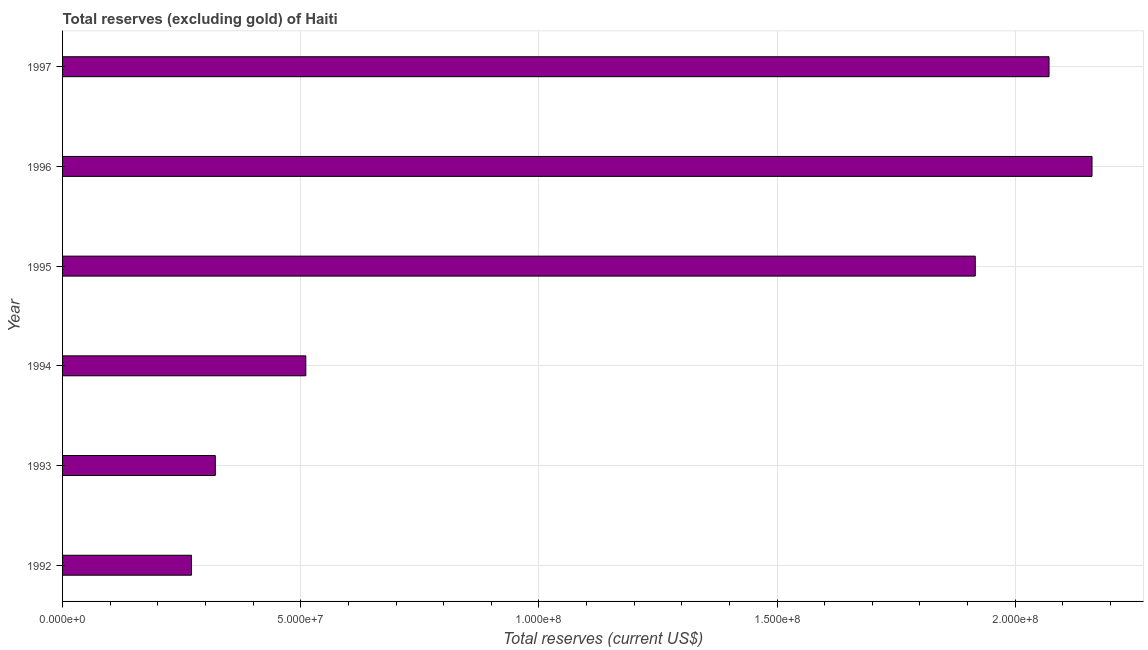Does the graph contain any zero values?
Provide a succinct answer. No. What is the title of the graph?
Your answer should be compact. Total reserves (excluding gold) of Haiti. What is the label or title of the X-axis?
Ensure brevity in your answer.  Total reserves (current US$). What is the label or title of the Y-axis?
Provide a succinct answer. Year. What is the total reserves (excluding gold) in 1992?
Offer a very short reply. 2.71e+07. Across all years, what is the maximum total reserves (excluding gold)?
Your answer should be very brief. 2.16e+08. Across all years, what is the minimum total reserves (excluding gold)?
Keep it short and to the point. 2.71e+07. What is the sum of the total reserves (excluding gold)?
Provide a short and direct response. 7.25e+08. What is the difference between the total reserves (excluding gold) in 1992 and 1993?
Your answer should be very brief. -4.99e+06. What is the average total reserves (excluding gold) per year?
Your response must be concise. 1.21e+08. What is the median total reserves (excluding gold)?
Offer a very short reply. 1.21e+08. What is the ratio of the total reserves (excluding gold) in 1993 to that in 1995?
Make the answer very short. 0.17. Is the total reserves (excluding gold) in 1992 less than that in 1997?
Your answer should be compact. Yes. What is the difference between the highest and the second highest total reserves (excluding gold)?
Your response must be concise. 9.03e+06. Is the sum of the total reserves (excluding gold) in 1992 and 1997 greater than the maximum total reserves (excluding gold) across all years?
Offer a very short reply. Yes. What is the difference between the highest and the lowest total reserves (excluding gold)?
Your answer should be very brief. 1.89e+08. In how many years, is the total reserves (excluding gold) greater than the average total reserves (excluding gold) taken over all years?
Ensure brevity in your answer.  3. Are all the bars in the graph horizontal?
Your answer should be very brief. Yes. How many years are there in the graph?
Provide a succinct answer. 6. What is the difference between two consecutive major ticks on the X-axis?
Offer a terse response. 5.00e+07. What is the Total reserves (current US$) in 1992?
Provide a succinct answer. 2.71e+07. What is the Total reserves (current US$) of 1993?
Keep it short and to the point. 3.21e+07. What is the Total reserves (current US$) of 1994?
Provide a succinct answer. 5.11e+07. What is the Total reserves (current US$) in 1995?
Your answer should be very brief. 1.92e+08. What is the Total reserves (current US$) in 1996?
Keep it short and to the point. 2.16e+08. What is the Total reserves (current US$) of 1997?
Keep it short and to the point. 2.07e+08. What is the difference between the Total reserves (current US$) in 1992 and 1993?
Provide a succinct answer. -4.99e+06. What is the difference between the Total reserves (current US$) in 1992 and 1994?
Provide a succinct answer. -2.40e+07. What is the difference between the Total reserves (current US$) in 1992 and 1995?
Your answer should be compact. -1.65e+08. What is the difference between the Total reserves (current US$) in 1992 and 1996?
Provide a short and direct response. -1.89e+08. What is the difference between the Total reserves (current US$) in 1992 and 1997?
Your answer should be compact. -1.80e+08. What is the difference between the Total reserves (current US$) in 1993 and 1994?
Ensure brevity in your answer.  -1.90e+07. What is the difference between the Total reserves (current US$) in 1993 and 1995?
Ensure brevity in your answer.  -1.60e+08. What is the difference between the Total reserves (current US$) in 1993 and 1996?
Your answer should be compact. -1.84e+08. What is the difference between the Total reserves (current US$) in 1993 and 1997?
Ensure brevity in your answer.  -1.75e+08. What is the difference between the Total reserves (current US$) in 1994 and 1995?
Your response must be concise. -1.41e+08. What is the difference between the Total reserves (current US$) in 1994 and 1996?
Your answer should be very brief. -1.65e+08. What is the difference between the Total reserves (current US$) in 1994 and 1997?
Your response must be concise. -1.56e+08. What is the difference between the Total reserves (current US$) in 1995 and 1996?
Provide a short and direct response. -2.45e+07. What is the difference between the Total reserves (current US$) in 1995 and 1997?
Provide a succinct answer. -1.55e+07. What is the difference between the Total reserves (current US$) in 1996 and 1997?
Offer a terse response. 9.03e+06. What is the ratio of the Total reserves (current US$) in 1992 to that in 1993?
Offer a very short reply. 0.84. What is the ratio of the Total reserves (current US$) in 1992 to that in 1994?
Offer a very short reply. 0.53. What is the ratio of the Total reserves (current US$) in 1992 to that in 1995?
Your answer should be compact. 0.14. What is the ratio of the Total reserves (current US$) in 1992 to that in 1997?
Make the answer very short. 0.13. What is the ratio of the Total reserves (current US$) in 1993 to that in 1994?
Offer a terse response. 0.63. What is the ratio of the Total reserves (current US$) in 1993 to that in 1995?
Your answer should be compact. 0.17. What is the ratio of the Total reserves (current US$) in 1993 to that in 1996?
Provide a short and direct response. 0.15. What is the ratio of the Total reserves (current US$) in 1993 to that in 1997?
Your answer should be compact. 0.15. What is the ratio of the Total reserves (current US$) in 1994 to that in 1995?
Provide a succinct answer. 0.27. What is the ratio of the Total reserves (current US$) in 1994 to that in 1996?
Provide a succinct answer. 0.24. What is the ratio of the Total reserves (current US$) in 1994 to that in 1997?
Ensure brevity in your answer.  0.25. What is the ratio of the Total reserves (current US$) in 1995 to that in 1996?
Your answer should be very brief. 0.89. What is the ratio of the Total reserves (current US$) in 1995 to that in 1997?
Your answer should be very brief. 0.93. What is the ratio of the Total reserves (current US$) in 1996 to that in 1997?
Provide a succinct answer. 1.04. 